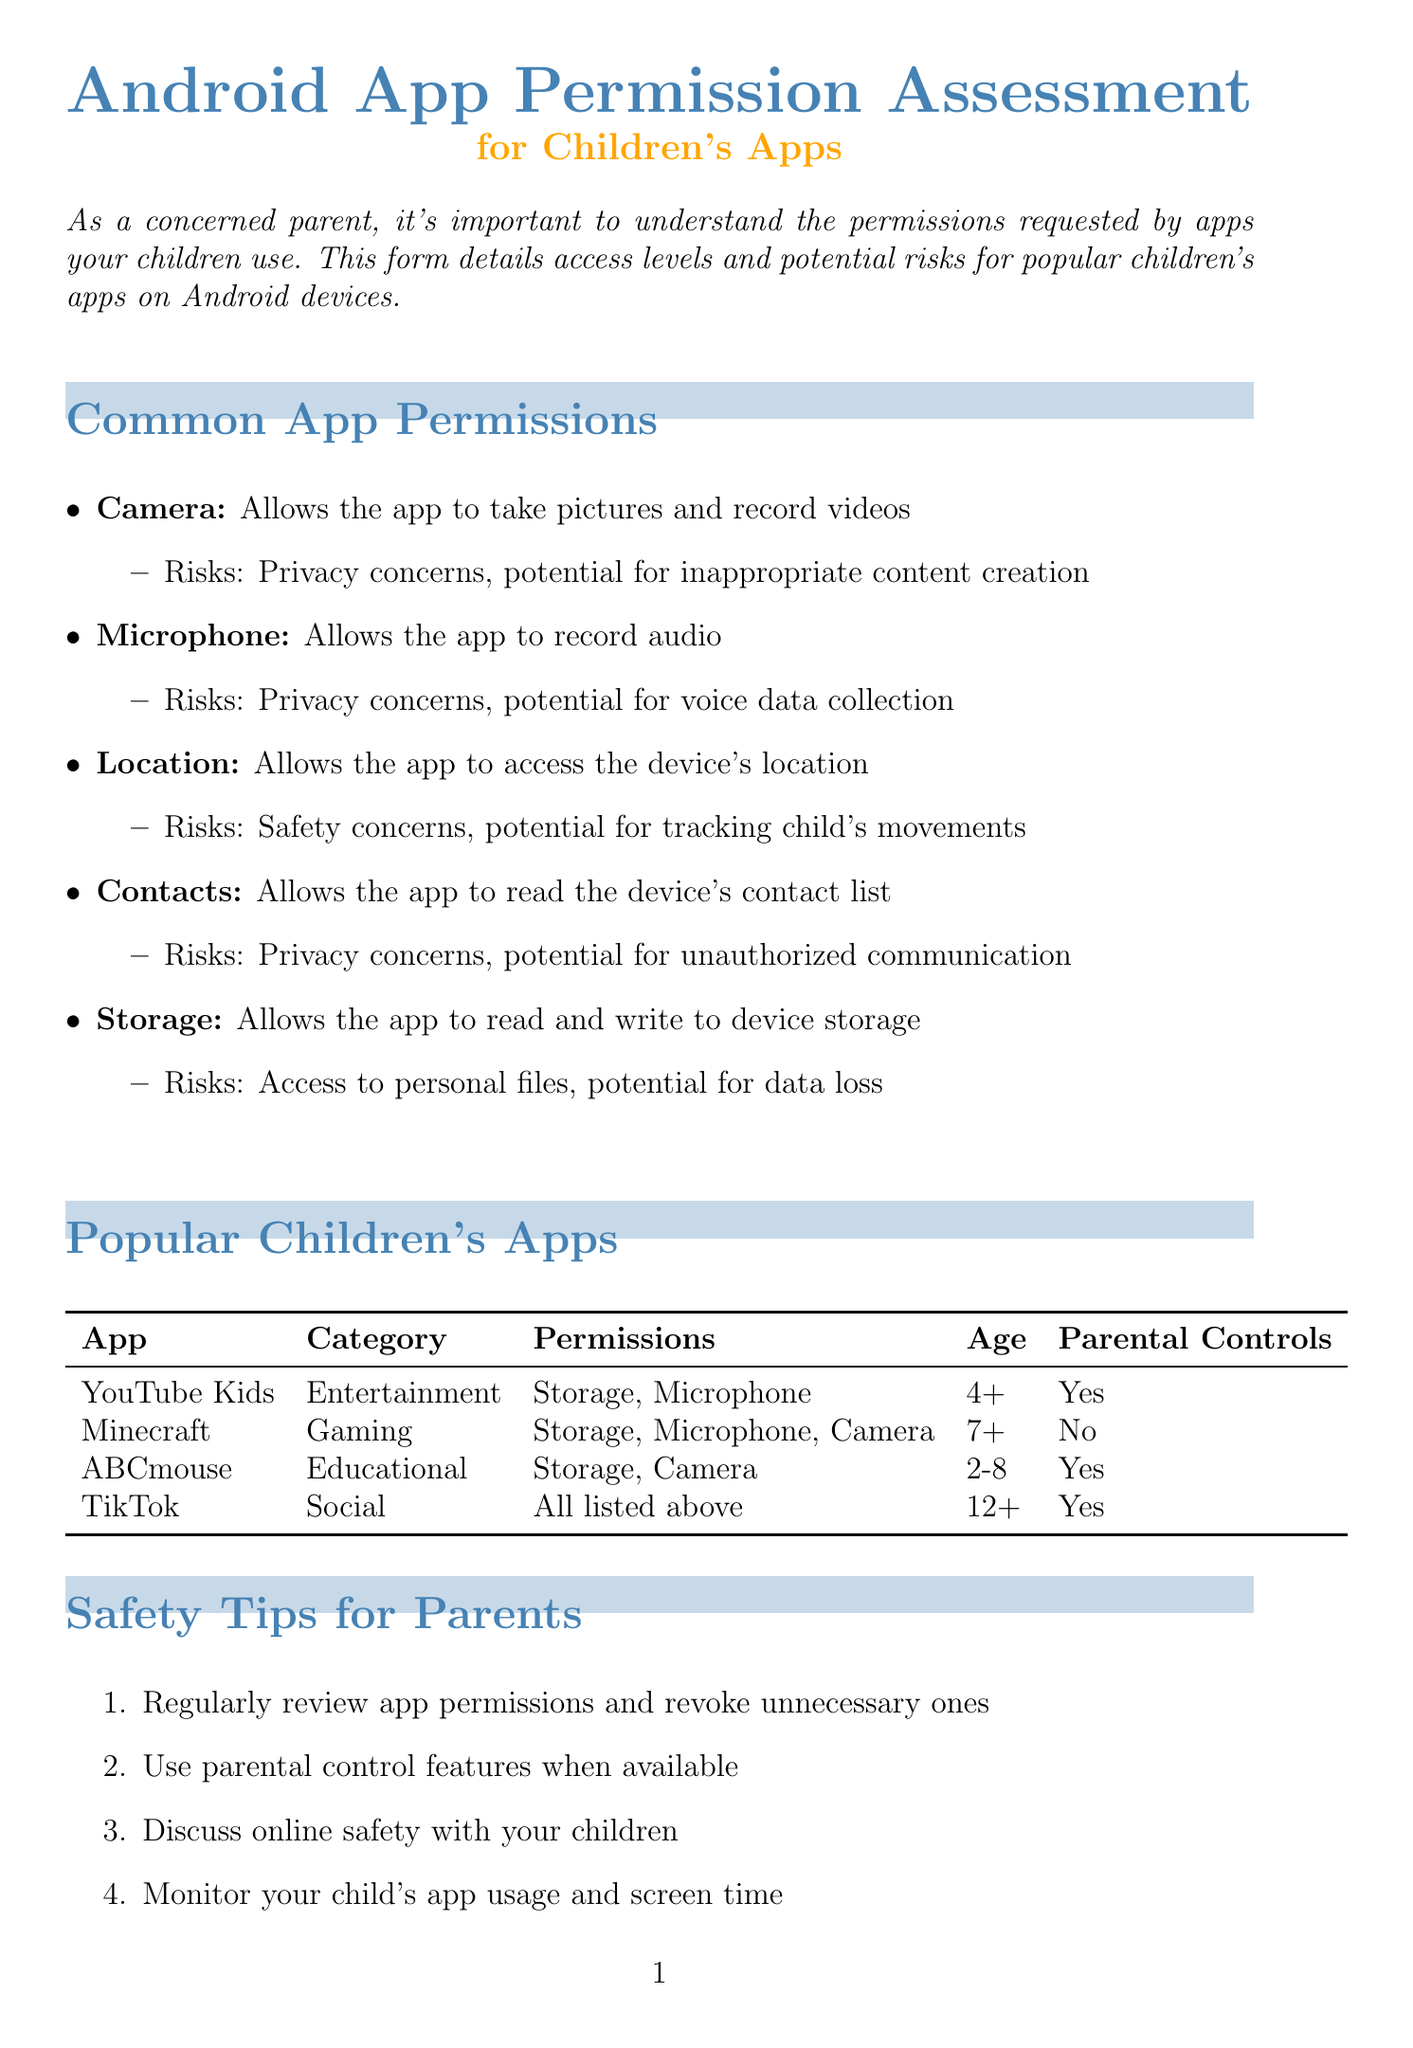What is the title of the form? The title of the form is stated in the document as "Android App Permission Assessment for Children's Apps."
Answer: Android App Permission Assessment for Children's Apps What is the age rating for YouTube Kids? The age rating for YouTube Kids is provided in the document, which is "4+."
Answer: 4+ Which app has parental control options? The document lists various apps, and parental control options are mentioned for YouTube Kids, ABCmouse, and TikTok.
Answer: YouTube Kids, ABCmouse, TikTok What permission does Minecraft request that relates to media? The document specifically lists requested permissions for Minecraft, which includes "Camera."
Answer: Camera What common permission poses safety concerns if location is shared publicly? The document mentions "Location" as a common permission that poses safety concerns if shared publicly.
Answer: Location What is one safety tip for parents mentioned in the document? The document lists various safety tips, one of which is to "Regularly review app permissions and revoke unnecessary ones."
Answer: Regularly review app permissions and revoke unnecessary ones How many permissions does TikTok request? The document specifies that TikTok requests multiple permissions including Camera, Microphone, Location, Contacts, and Storage, totaling five permissions.
Answer: Five Is ABCmouse rated for children aged 2 to 8? The age rating for ABCmouse is indicated clearly in the document as "2-8."
Answer: Yes What resource helps manage children's Android devices? The document identifies "Google Family Link" as a resource for managing children's Android devices.
Answer: Google Family Link 